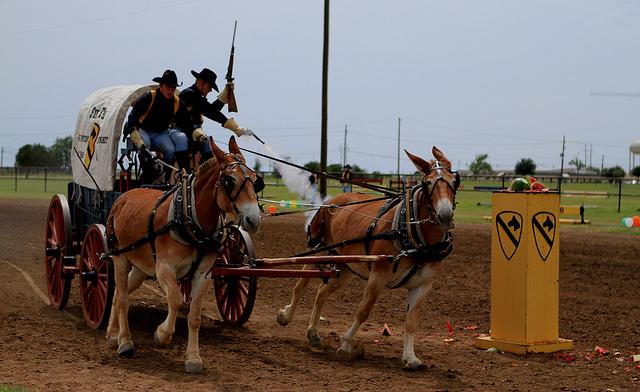Are those horses or donkeys?
Concise answer only. Donkeys. How many horses?
Answer briefly. 2. What color are the wheels?'?
Short answer required. Red. Would this scene be considered romantic?
Answer briefly. No. Where is the green in the photo?
Answer briefly. Grass. What is the surface of the street the horses are walking on comprised of?
Concise answer only. Dirt. What type of event are they participating in?
Concise answer only. Race. 